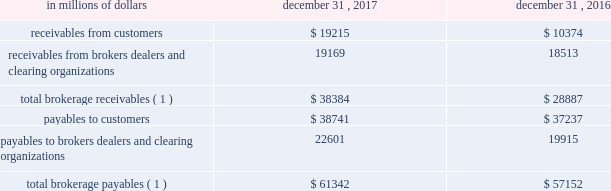12 .
Brokerage receivables and brokerage payables citi has receivables and payables for financial instruments sold to and purchased from brokers , dealers and customers , which arise in the ordinary course of business .
Citi is exposed to risk of loss from the inability of brokers , dealers or customers to pay for purchases or to deliver the financial instruments sold , in which case citi would have to sell or purchase the financial instruments at prevailing market prices .
Credit risk is reduced to the extent that an exchange or clearing organization acts as a counterparty to the transaction and replaces the broker , dealer or customer in question .
Citi seeks to protect itself from the risks associated with customer activities by requiring customers to maintain margin collateral in compliance with regulatory and internal guidelines .
Margin levels are monitored daily , and customers deposit additional collateral as required .
Where customers cannot meet collateral requirements , citi may liquidate sufficient underlying financial instruments to bring the customer into compliance with the required margin level .
Exposure to credit risk is impacted by market volatility , which may impair the ability of clients to satisfy their obligations to citi .
Credit limits are established and closely monitored for customers and for brokers and dealers engaged in forwards , futures and other transactions deemed to be credit sensitive .
Brokerage receivables and brokerage payables consisted of the following: .
Payables to brokers , dealers and clearing organizations 22601 19915 total brokerage payables ( 1 ) $ 61342 $ 57152 ( 1 ) includes brokerage receivables and payables recorded by citi broker- dealer entities that are accounted for in accordance with the aicpa accounting guide for brokers and dealers in securities as codified in asc 940-320. .
What was the percentage increased in the total brokerage payables from 2016 to 2017? 
Rationale: the total brokerage payables increased by 7.3% from 2016 to 2017
Computations: ((61342 - 57152) / 57152)
Answer: 0.07331. 